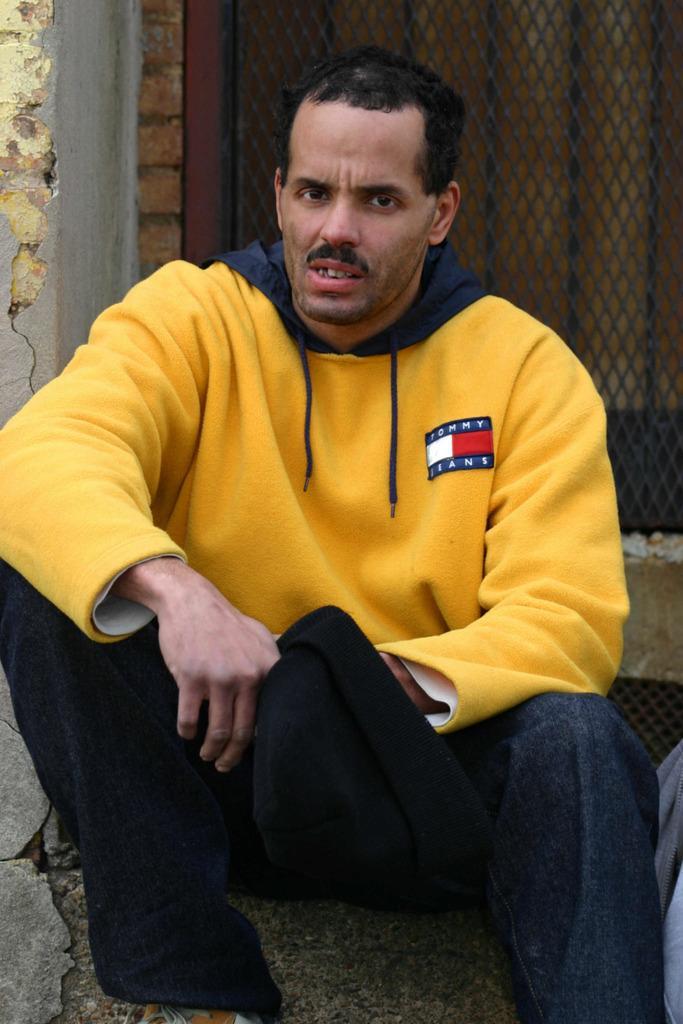Could you give a brief overview of what you see in this image? A man is sitting wearing a yellow color hoodie and a pant. He is holding a black cap in his hand. There is a window behind him which has a mesh. 